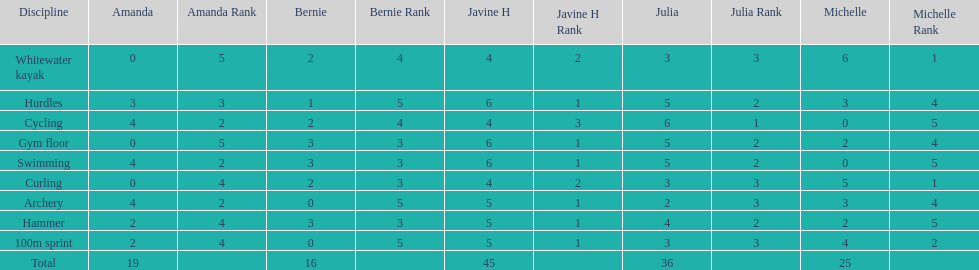What are the number of points bernie scored in hurdles? 1. 